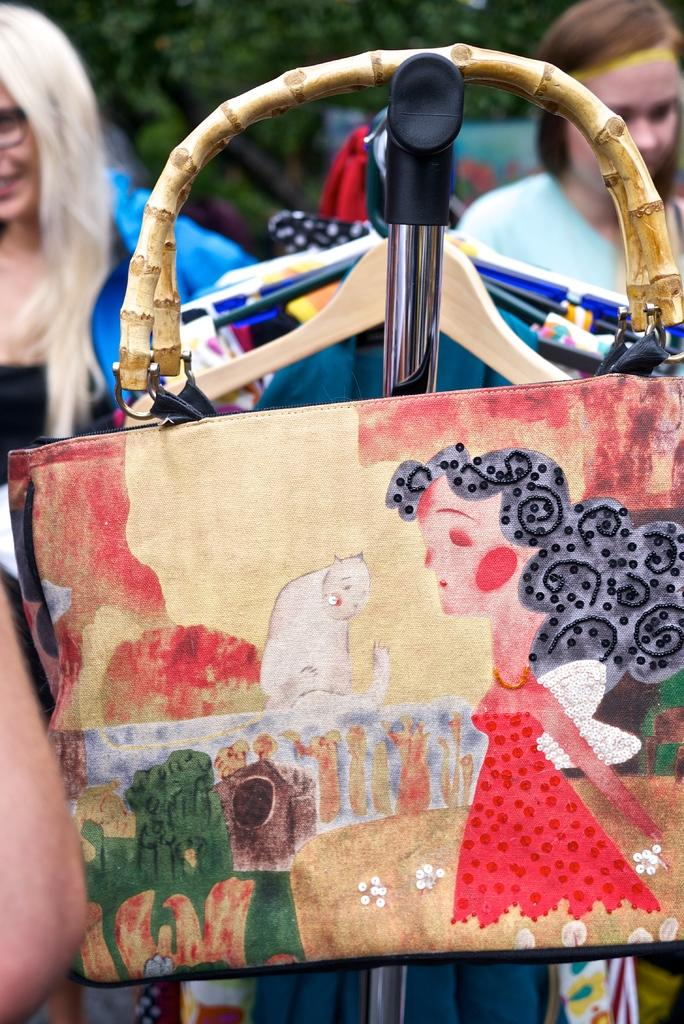What object is featured in the image? There is a handbag in the image. What images are on the handbag? The handbag has a cat image and a girl image on it. Who is present in the image? There are two women standing behind the handbag. What type of hat is the governor wearing in the image? There is no governor or hat present in the image; it features a handbag with images of a cat and a girl, and two women standing behind it. 